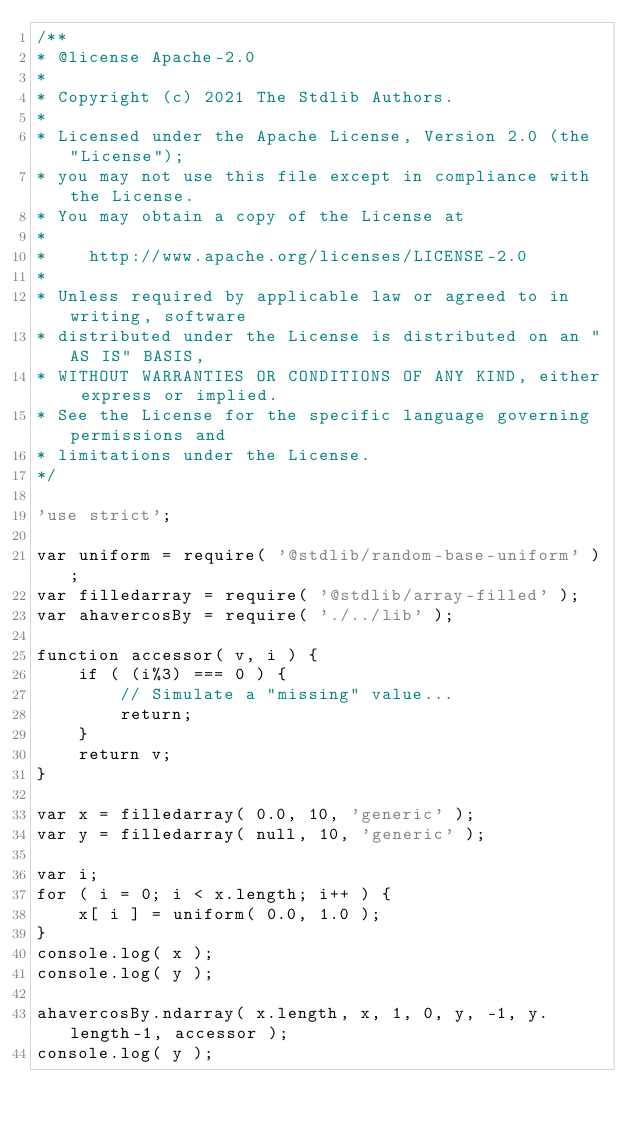<code> <loc_0><loc_0><loc_500><loc_500><_JavaScript_>/**
* @license Apache-2.0
*
* Copyright (c) 2021 The Stdlib Authors.
*
* Licensed under the Apache License, Version 2.0 (the "License");
* you may not use this file except in compliance with the License.
* You may obtain a copy of the License at
*
*    http://www.apache.org/licenses/LICENSE-2.0
*
* Unless required by applicable law or agreed to in writing, software
* distributed under the License is distributed on an "AS IS" BASIS,
* WITHOUT WARRANTIES OR CONDITIONS OF ANY KIND, either express or implied.
* See the License for the specific language governing permissions and
* limitations under the License.
*/

'use strict';

var uniform = require( '@stdlib/random-base-uniform' );
var filledarray = require( '@stdlib/array-filled' );
var ahavercosBy = require( './../lib' );

function accessor( v, i ) {
	if ( (i%3) === 0 ) {
		// Simulate a "missing" value...
		return;
	}
	return v;
}

var x = filledarray( 0.0, 10, 'generic' );
var y = filledarray( null, 10, 'generic' );

var i;
for ( i = 0; i < x.length; i++ ) {
	x[ i ] = uniform( 0.0, 1.0 );
}
console.log( x );
console.log( y );

ahavercosBy.ndarray( x.length, x, 1, 0, y, -1, y.length-1, accessor );
console.log( y );
</code> 